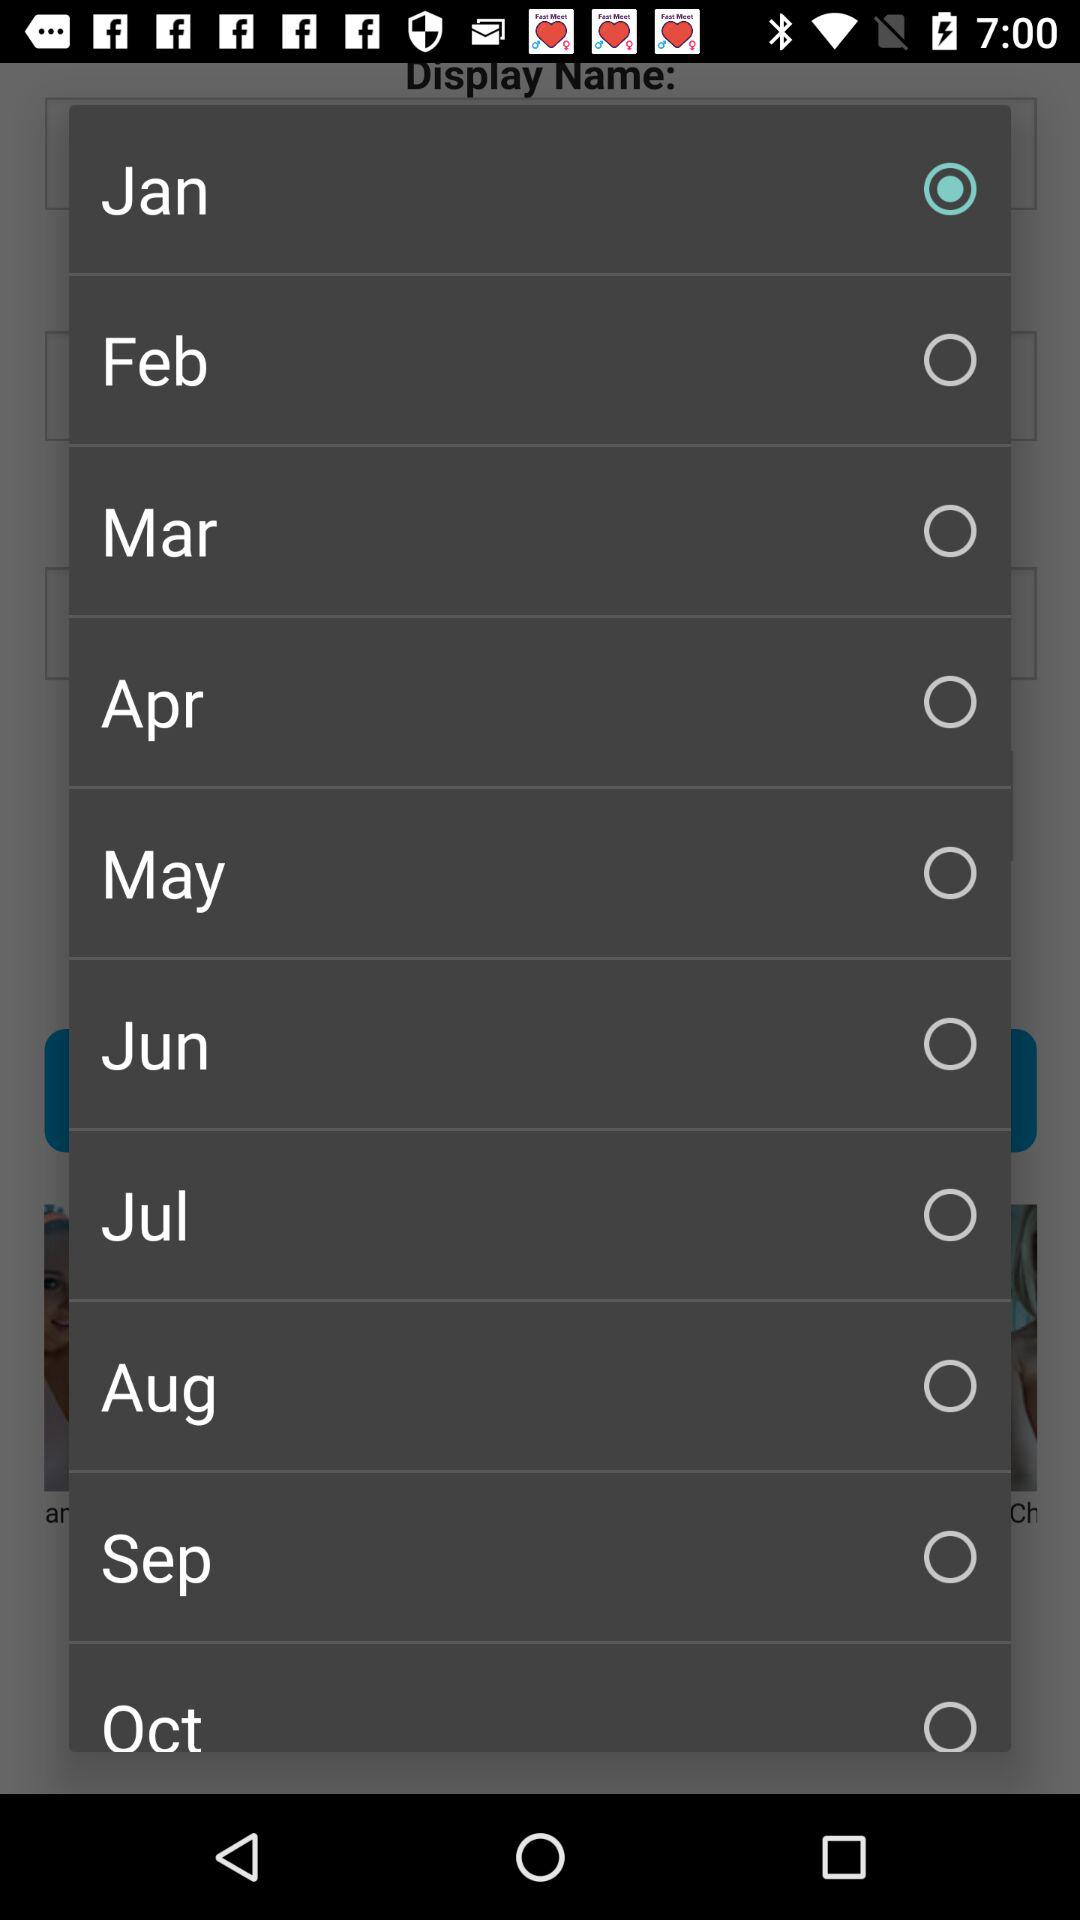What is the name of the selected month? The selected month is January. 